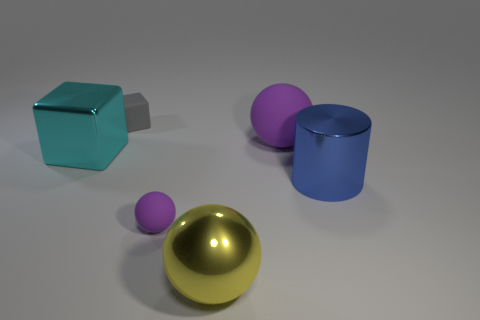How many things are metallic objects that are on the left side of the large shiny ball or big balls to the right of the yellow metallic object?
Ensure brevity in your answer.  2. What number of things have the same color as the tiny sphere?
Keep it short and to the point. 1. The big matte object that is the same shape as the tiny purple rubber object is what color?
Offer a terse response. Purple. There is a big object that is both behind the blue shiny cylinder and in front of the big purple matte ball; what is its shape?
Provide a short and direct response. Cube. Are there more purple things than tiny gray shiny balls?
Offer a terse response. Yes. What material is the small gray block?
Provide a succinct answer. Rubber. There is another thing that is the same shape as the gray object; what size is it?
Your answer should be very brief. Large. Is there a large blue shiny cylinder in front of the cube that is in front of the big purple matte sphere?
Your answer should be compact. Yes. Does the big rubber ball have the same color as the small sphere?
Give a very brief answer. Yes. What number of other things are the same shape as the large purple thing?
Keep it short and to the point. 2. 